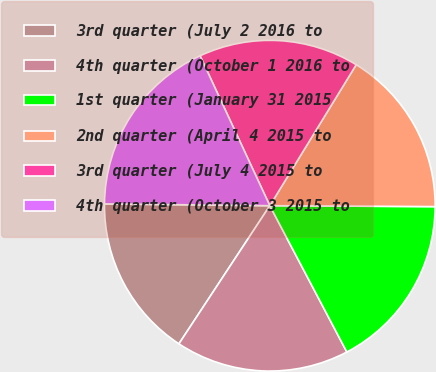<chart> <loc_0><loc_0><loc_500><loc_500><pie_chart><fcel>3rd quarter (July 2 2016 to<fcel>4th quarter (October 1 2016 to<fcel>1st quarter (January 31 2015<fcel>2nd quarter (April 4 2015 to<fcel>3rd quarter (July 4 2015 to<fcel>4th quarter (October 3 2015 to<nl><fcel>15.91%<fcel>16.98%<fcel>17.2%<fcel>16.34%<fcel>15.68%<fcel>17.9%<nl></chart> 